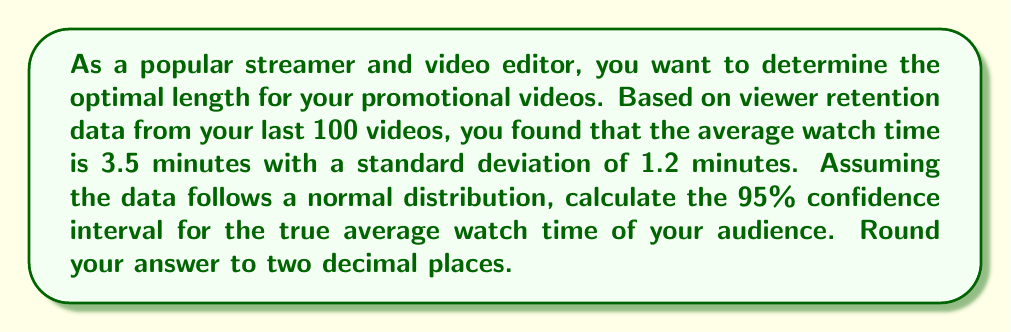What is the answer to this math problem? To calculate the 95% confidence interval, we'll use the formula:

$$ \text{CI} = \bar{x} \pm t_{\alpha/2} \cdot \frac{s}{\sqrt{n}} $$

Where:
$\bar{x}$ = sample mean = 3.5 minutes
$s$ = sample standard deviation = 1.2 minutes
$n$ = sample size = 100
$t_{\alpha/2}$ = t-value for 95% confidence interval with 99 degrees of freedom

Step 1: Find the t-value
For a 95% CI with 99 degrees of freedom, $t_{\alpha/2} \approx 1.984$ (from t-distribution table)

Step 2: Calculate the margin of error
$$ \text{Margin of Error} = t_{\alpha/2} \cdot \frac{s}{\sqrt{n}} = 1.984 \cdot \frac{1.2}{\sqrt{100}} \approx 0.238 $$

Step 3: Calculate the confidence interval
$$ \text{CI} = 3.5 \pm 0.238 $$
$$ \text{Lower bound} = 3.5 - 0.238 = 3.262 $$
$$ \text{Upper bound} = 3.5 + 0.238 = 3.738 $$

Step 4: Round to two decimal places
$$ \text{CI} = (3.26, 3.74) $$
Answer: (3.26, 3.74) minutes 